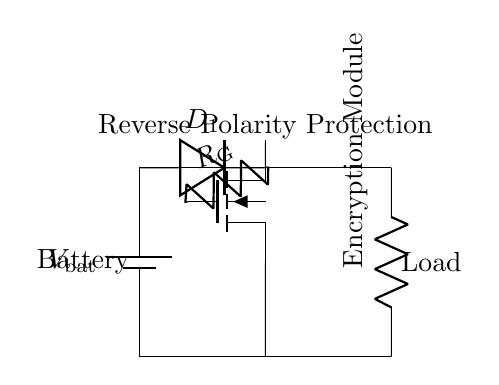What type of diode is used in this circuit? The circuit shows a diode labeled D1, indicating it is a regular diode typically used for rectification and in reverse polarity protection.
Answer: Diode What is the role of the MOSFET in this circuit? The MOSFET acts as a switch that controls current flow, ensuring that the encryption module receives the correct polarity voltage when the battery is connected properly.
Answer: Switch How many components are in the circuit? The circuit consists of four primary components: one battery, one diode, one resistor, and one MOSFET.
Answer: Four What does R_G represent in this circuit? R_G is a resistor connected between the gate of the MOSFET and the positive terminal of the battery, providing stability and control for the MOSFET operation.
Answer: Resistor In what condition will the encryption module receive power? The encryption module will receive power when the battery is connected with the correct polarity, allowing current to flow through the MOSFET and diode.
Answer: Correct polarity What would happen if the battery is connected with reverse polarity? If the battery is connected with reverse polarity, the diode D1 will block the current flow, preventing power from reaching the encryption module and protecting it from damage.
Answer: No power 